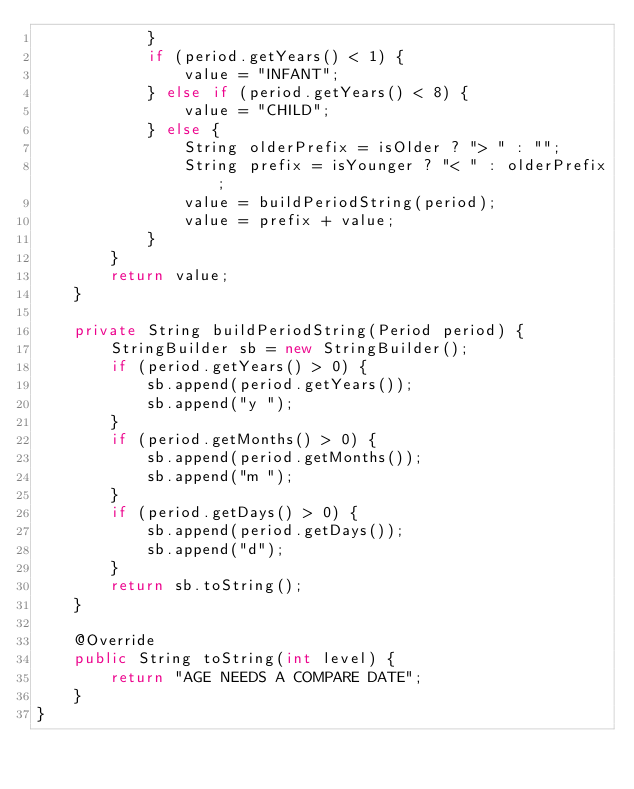<code> <loc_0><loc_0><loc_500><loc_500><_Java_>            }
            if (period.getYears() < 1) {
                value = "INFANT";
            } else if (period.getYears() < 8) {
                value = "CHILD";
            } else {
                String olderPrefix = isOlder ? "> " : "";
                String prefix = isYounger ? "< " : olderPrefix;
                value = buildPeriodString(period);
                value = prefix + value;
            }
        }
        return value;
    }

    private String buildPeriodString(Period period) {
        StringBuilder sb = new StringBuilder();
        if (period.getYears() > 0) {
            sb.append(period.getYears());
            sb.append("y ");
        }
        if (period.getMonths() > 0) {
            sb.append(period.getMonths());
            sb.append("m ");
        }
        if (period.getDays() > 0) {
            sb.append(period.getDays());
            sb.append("d");
        }
        return sb.toString();
    }

    @Override
    public String toString(int level) {
        return "AGE NEEDS A COMPARE DATE";
    }
}
</code> 